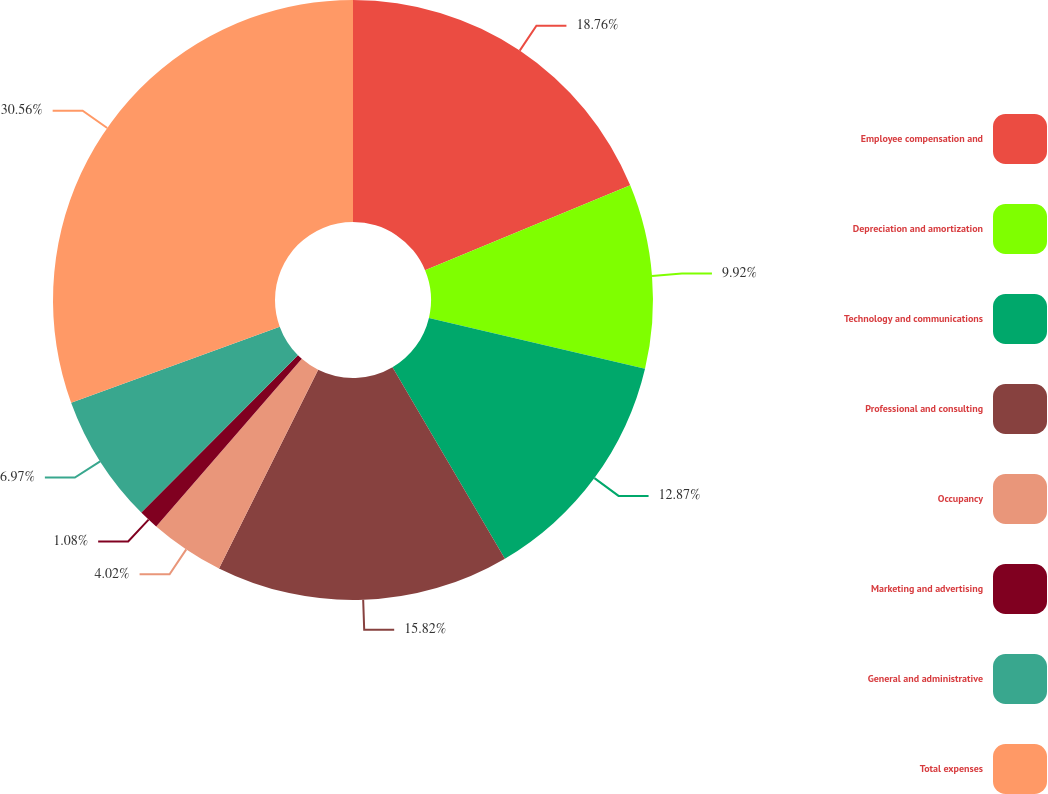Convert chart. <chart><loc_0><loc_0><loc_500><loc_500><pie_chart><fcel>Employee compensation and<fcel>Depreciation and amortization<fcel>Technology and communications<fcel>Professional and consulting<fcel>Occupancy<fcel>Marketing and advertising<fcel>General and administrative<fcel>Total expenses<nl><fcel>18.76%<fcel>9.92%<fcel>12.87%<fcel>15.82%<fcel>4.02%<fcel>1.08%<fcel>6.97%<fcel>30.56%<nl></chart> 